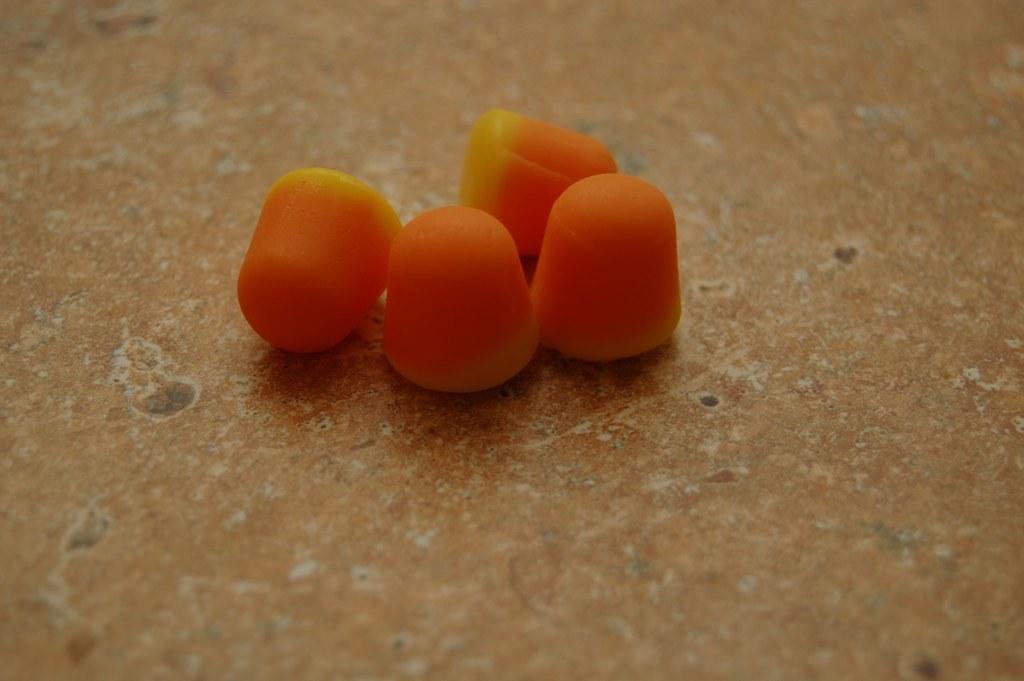Could you give a brief overview of what you see in this image? In the picture I can see the fruits on the floor. 